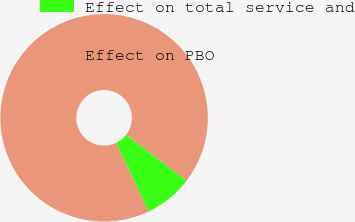<chart> <loc_0><loc_0><loc_500><loc_500><pie_chart><fcel>Effect on total service and<fcel>Effect on PBO<nl><fcel>7.57%<fcel>92.43%<nl></chart> 